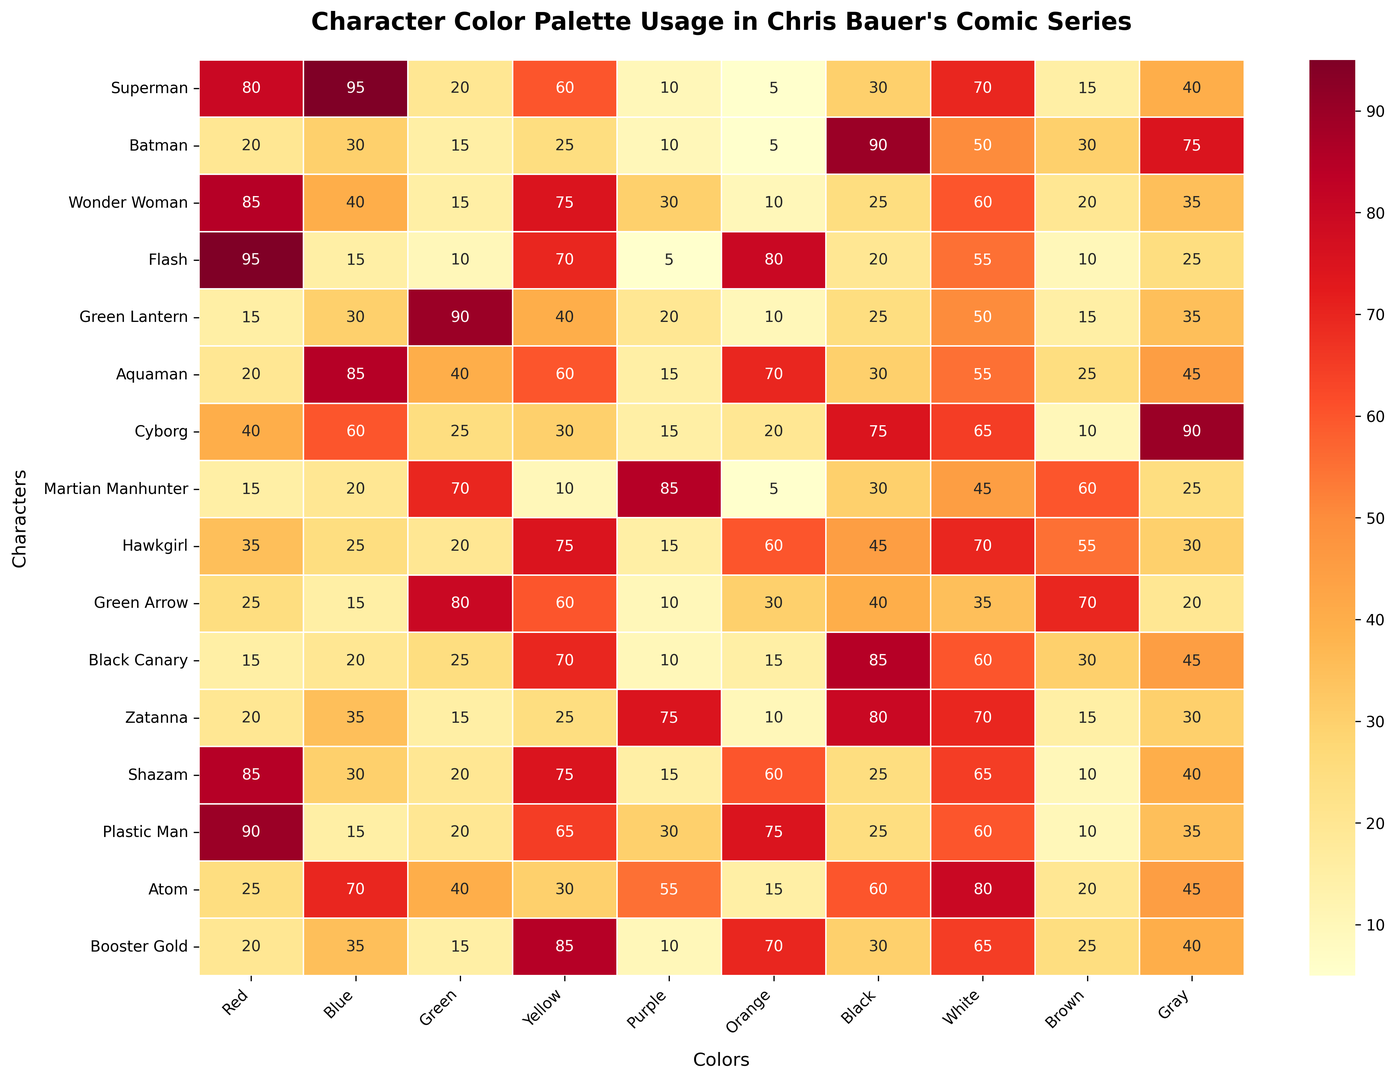What's the most frequently used color for Batman? Look at the row for Batman and find the highest value among the color columns. The highest value is 90 in the Black column.
Answer: Black What are the two least used colors for Superman? Refer to the row for Superman and identify the two lowest values across all color columns. The lowest values are 5 and 10 in the Orange and Purple columns, respectively.
Answer: Orange and Purple Which character uses the color Blue the most? Compare the values in the Blue column for all characters. The highest value is 95 for Superman.
Answer: Superman By how much does Flash's use of Orange exceed Aquaman's use of Orange? Look at the values in the Orange column for Flash and Aquaman. Flash has 80 and Aquaman has 70. The difference is 80 - 70 = 10.
Answer: 10 What is the average usage of the color Red across all characters? Sum up all values in the Red column and divide by the total number of characters (15). The sum is 600, so the average is 600 / 15 = 40.
Answer: 40 Which character uses the color Green the most and which uses it the least? Find the highest and lowest values in the Green column. Green Lantern has the highest (90), and Flash has the lowest (10), which is shared with several others.
Answer: Green Lantern and Flash How often does Martian Manhunter use more than 50% of one color in his palette? Look at the row for Martian Manhunter and count values greater than 50. There are two such values: Green (70) and Purple (85).
Answer: 2 Which two characters have the most similar usage pattern for the color Purple? Compare the values in the Purple column for all characters. The most similar values are for Martian Manhunter (85) and Atom (55).
Answer: Martian Manhunter and Atom Does Wonder Woman use Yellow more or less frequently than Plastic Man? Look at the values in the Yellow column for Wonder Woman (75) and Plastic Man (65). 75 > 65, so Wonder Woman uses Yellow more frequently.
Answer: More What colors does Hawkgirl use more than 50 times in the series? Refer to the row for Hawkgirl and identify the columns with values greater than 50. These are Yellow (75), Blue (55), and Brown (70).
Answer: Yellow, Blue, and Brown 